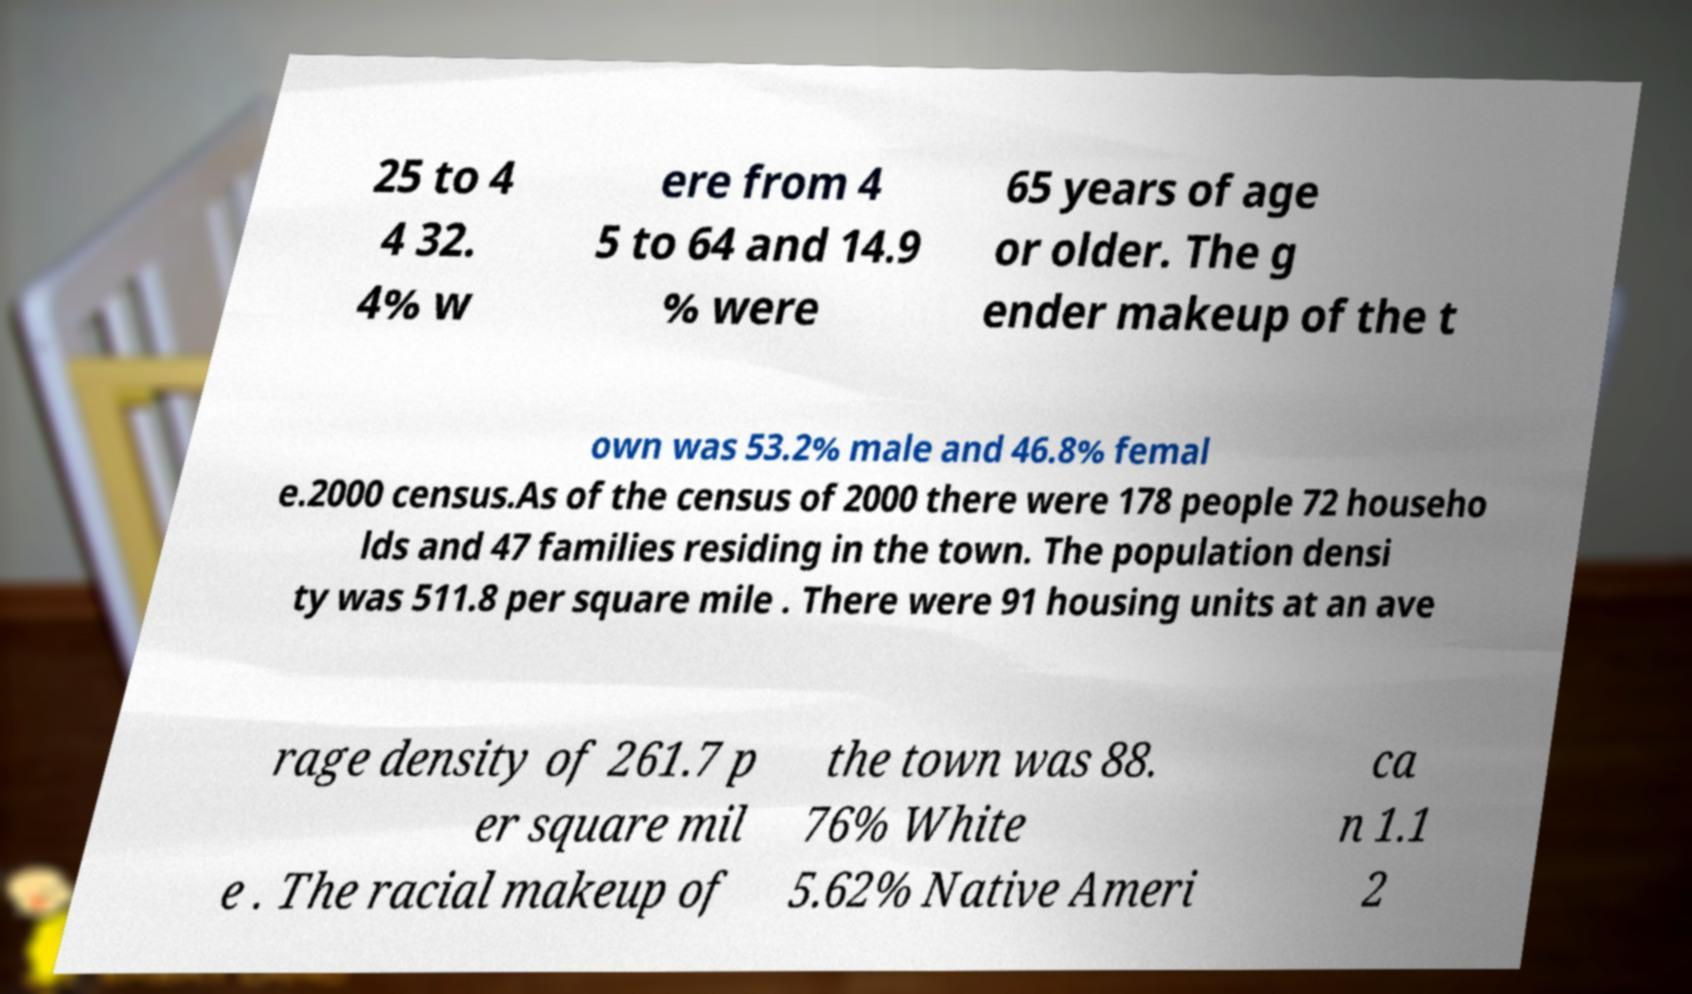Please read and relay the text visible in this image. What does it say? 25 to 4 4 32. 4% w ere from 4 5 to 64 and 14.9 % were 65 years of age or older. The g ender makeup of the t own was 53.2% male and 46.8% femal e.2000 census.As of the census of 2000 there were 178 people 72 househo lds and 47 families residing in the town. The population densi ty was 511.8 per square mile . There were 91 housing units at an ave rage density of 261.7 p er square mil e . The racial makeup of the town was 88. 76% White 5.62% Native Ameri ca n 1.1 2 